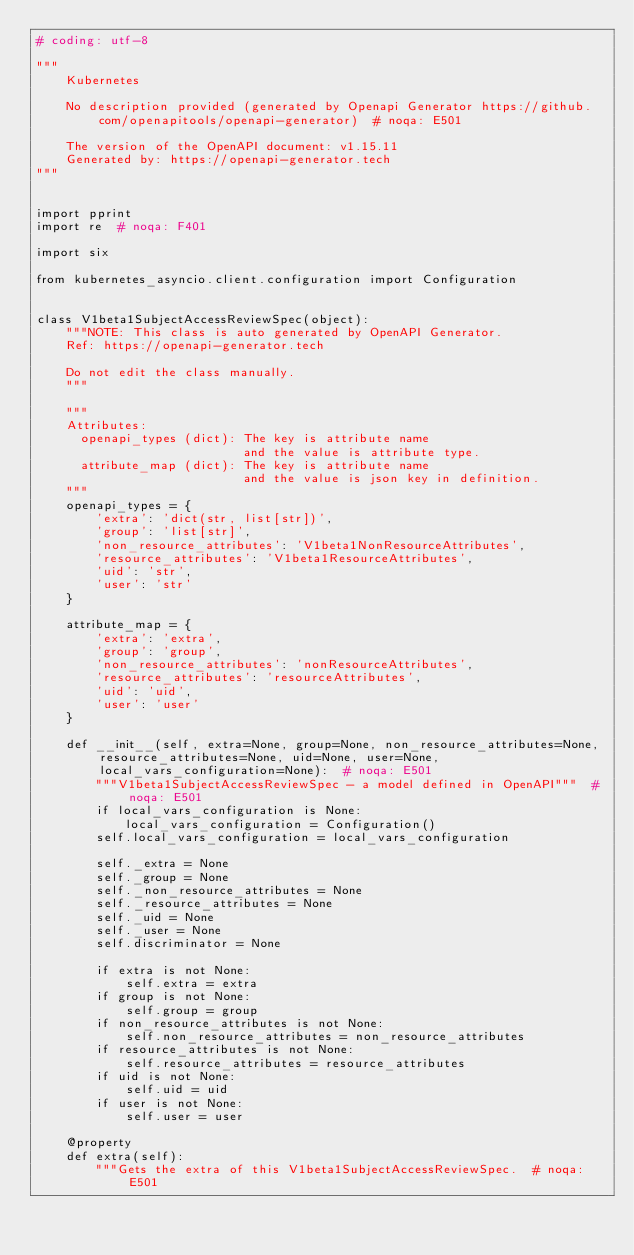Convert code to text. <code><loc_0><loc_0><loc_500><loc_500><_Python_># coding: utf-8

"""
    Kubernetes

    No description provided (generated by Openapi Generator https://github.com/openapitools/openapi-generator)  # noqa: E501

    The version of the OpenAPI document: v1.15.11
    Generated by: https://openapi-generator.tech
"""


import pprint
import re  # noqa: F401

import six

from kubernetes_asyncio.client.configuration import Configuration


class V1beta1SubjectAccessReviewSpec(object):
    """NOTE: This class is auto generated by OpenAPI Generator.
    Ref: https://openapi-generator.tech

    Do not edit the class manually.
    """

    """
    Attributes:
      openapi_types (dict): The key is attribute name
                            and the value is attribute type.
      attribute_map (dict): The key is attribute name
                            and the value is json key in definition.
    """
    openapi_types = {
        'extra': 'dict(str, list[str])',
        'group': 'list[str]',
        'non_resource_attributes': 'V1beta1NonResourceAttributes',
        'resource_attributes': 'V1beta1ResourceAttributes',
        'uid': 'str',
        'user': 'str'
    }

    attribute_map = {
        'extra': 'extra',
        'group': 'group',
        'non_resource_attributes': 'nonResourceAttributes',
        'resource_attributes': 'resourceAttributes',
        'uid': 'uid',
        'user': 'user'
    }

    def __init__(self, extra=None, group=None, non_resource_attributes=None, resource_attributes=None, uid=None, user=None, local_vars_configuration=None):  # noqa: E501
        """V1beta1SubjectAccessReviewSpec - a model defined in OpenAPI"""  # noqa: E501
        if local_vars_configuration is None:
            local_vars_configuration = Configuration()
        self.local_vars_configuration = local_vars_configuration

        self._extra = None
        self._group = None
        self._non_resource_attributes = None
        self._resource_attributes = None
        self._uid = None
        self._user = None
        self.discriminator = None

        if extra is not None:
            self.extra = extra
        if group is not None:
            self.group = group
        if non_resource_attributes is not None:
            self.non_resource_attributes = non_resource_attributes
        if resource_attributes is not None:
            self.resource_attributes = resource_attributes
        if uid is not None:
            self.uid = uid
        if user is not None:
            self.user = user

    @property
    def extra(self):
        """Gets the extra of this V1beta1SubjectAccessReviewSpec.  # noqa: E501
</code> 